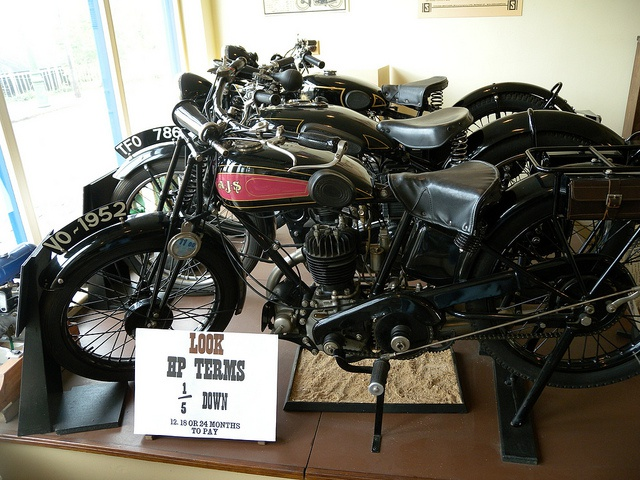Describe the objects in this image and their specific colors. I can see motorcycle in white, black, gray, and darkgray tones, motorcycle in white, black, gray, and darkgray tones, and motorcycle in white, black, ivory, gray, and darkgray tones in this image. 